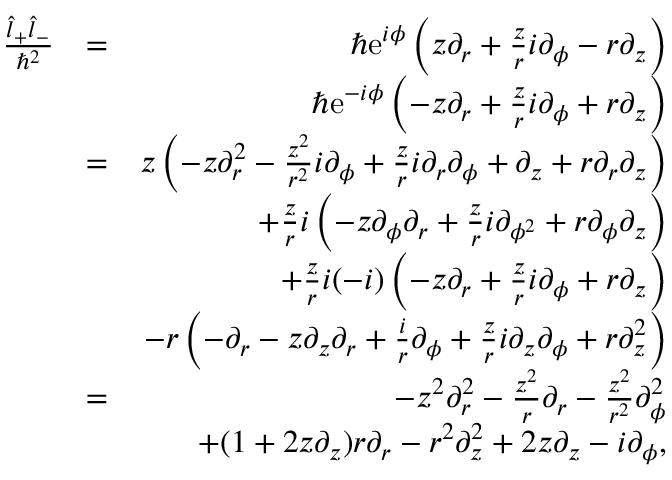Convert formula to latex. <formula><loc_0><loc_0><loc_500><loc_500>\begin{array} { r l r } { \frac { \hat { l } _ { + } \hat { l } _ { - } } { \hbar { ^ } { 2 } } } & { = } & { \hbar { e } ^ { i \phi } \left ( z \partial _ { r } + \frac { z } { r } i \partial _ { \phi } - r \partial _ { z } \right ) } \\ & { \hbar { e } ^ { - i \phi } \left ( - z \partial _ { r } + \frac { z } { r } i \partial _ { \phi } + r \partial _ { z } \right ) } \\ & { = } & { z \left ( - z \partial _ { r } ^ { 2 } - \frac { z ^ { 2 } } { r ^ { 2 } } i \partial _ { \phi } + \frac { z } { r } i \partial _ { r } \partial _ { \phi } + \partial _ { z } + r \partial _ { r } \partial _ { z } \right ) } \\ & { + \frac { z } { r } i \left ( - z \partial _ { \phi } \partial _ { r } + \frac { z } { r } i \partial _ { \phi ^ { 2 } } + r \partial _ { \phi } \partial _ { z } \right ) } \\ & { + \frac { z } { r } i ( - i ) \left ( - z \partial _ { r } + \frac { z } { r } i \partial _ { \phi } + r \partial _ { z } \right ) } \\ & { - r \left ( - \partial _ { r } - z \partial _ { z } \partial _ { r } + \frac { i } { r } \partial _ { \phi } + \frac { z } { r } i \partial _ { z } \partial _ { \phi } + r \partial _ { z } ^ { 2 } \right ) } \\ & { = } & { - z ^ { 2 } \partial _ { r } ^ { 2 } - \frac { z ^ { 2 } } { r } \partial _ { r } - \frac { z ^ { 2 } } { r ^ { 2 } } \partial _ { \phi } ^ { 2 } } \\ & { + ( 1 + 2 z \partial _ { z } ) r \partial _ { r } - r ^ { 2 } \partial _ { z } ^ { 2 } + 2 z \partial _ { z } - i \partial _ { \phi } , } \end{array}</formula> 